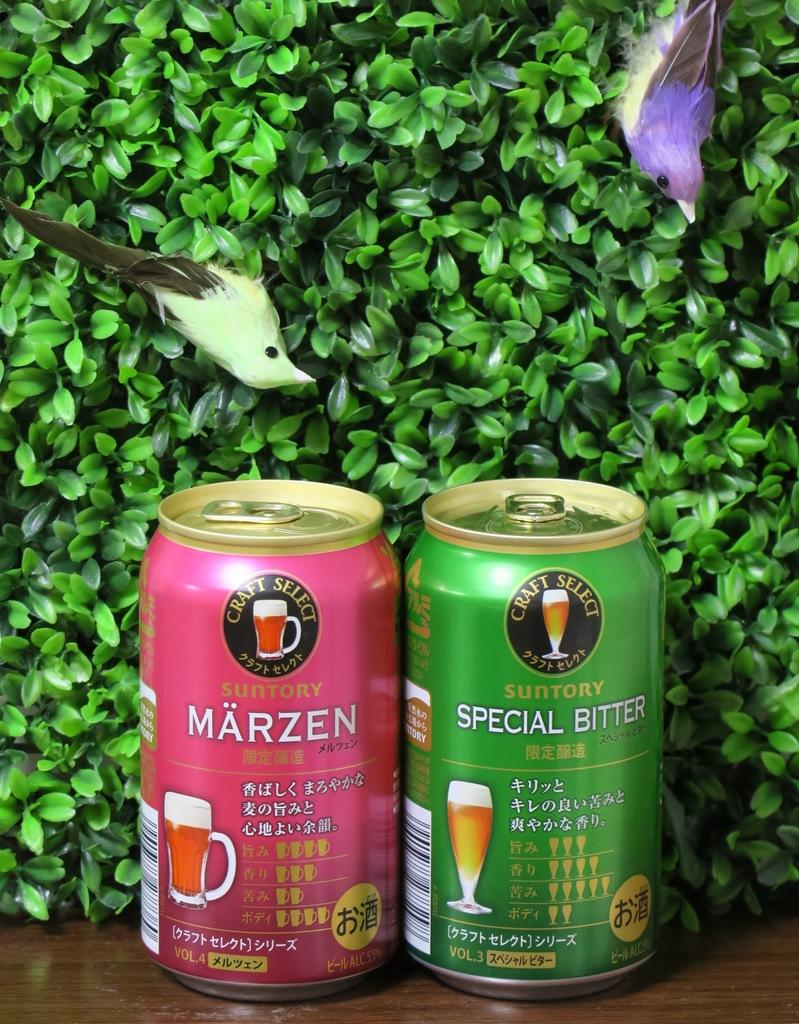<image>
Offer a succinct explanation of the picture presented. A can of Craft Select Märzen and Special Bitter. 